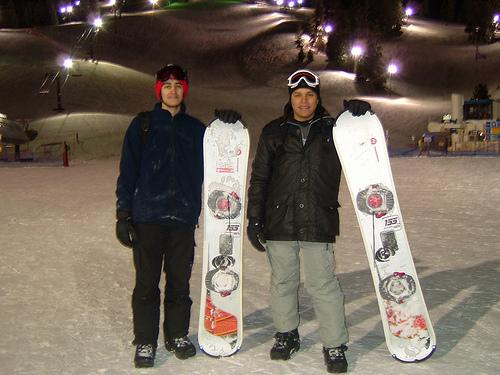Why are the lights on at this ski resort? nighttime 